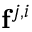Convert formula to latex. <formula><loc_0><loc_0><loc_500><loc_500>f ^ { j , i }</formula> 